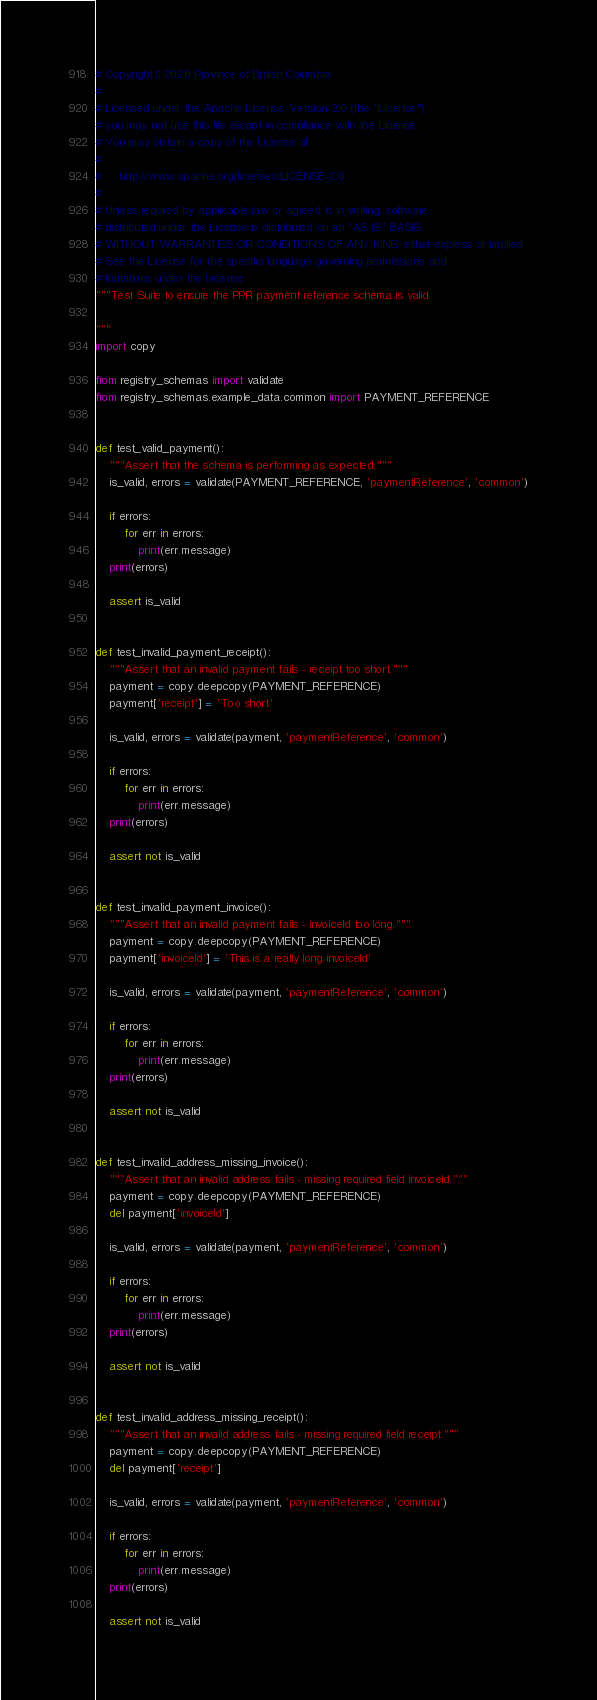Convert code to text. <code><loc_0><loc_0><loc_500><loc_500><_Python_># Copyright © 2020 Province of British Columbia
#
# Licensed under the Apache License, Version 2.0 (the "License");
# you may not use this file except in compliance with the License.
# You may obtain a copy of the License at
#
#     http://www.apache.org/licenses/LICENSE-2.0
#
# Unless required by applicable law or agreed to in writing, software
# distributed under the License is distributed on an "AS IS" BASIS,
# WITHOUT WARRANTIES OR CONDITIONS OF ANY KIND, either express or implied.
# See the License for the specific language governing permissions and
# limitations under the License.
"""Test Suite to ensure the PPR payment reference schema is valid.

"""
import copy

from registry_schemas import validate
from registry_schemas.example_data.common import PAYMENT_REFERENCE


def test_valid_payment():
    """Assert that the schema is performing as expected."""
    is_valid, errors = validate(PAYMENT_REFERENCE, 'paymentReference', 'common')

    if errors:
        for err in errors:
            print(err.message)
    print(errors)

    assert is_valid


def test_invalid_payment_receipt():
    """Assert that an invalid payment fails - receipt too short."""
    payment = copy.deepcopy(PAYMENT_REFERENCE)
    payment['receipt'] = 'Too short'

    is_valid, errors = validate(payment, 'paymentReference', 'common')

    if errors:
        for err in errors:
            print(err.message)
    print(errors)

    assert not is_valid


def test_invalid_payment_invoice():
    """Assert that an invalid payment fails - invoiceId too long."""
    payment = copy.deepcopy(PAYMENT_REFERENCE)
    payment['invoiceId'] = 'This is a really long invoiceId'

    is_valid, errors = validate(payment, 'paymentReference', 'common')

    if errors:
        for err in errors:
            print(err.message)
    print(errors)

    assert not is_valid


def test_invalid_address_missing_invoice():
    """Assert that an invalid address fails - missing required field invoiceId."""
    payment = copy.deepcopy(PAYMENT_REFERENCE)
    del payment['invoiceId']

    is_valid, errors = validate(payment, 'paymentReference', 'common')

    if errors:
        for err in errors:
            print(err.message)
    print(errors)

    assert not is_valid


def test_invalid_address_missing_receipt():
    """Assert that an invalid address fails - missing required field receipt."""
    payment = copy.deepcopy(PAYMENT_REFERENCE)
    del payment['receipt']

    is_valid, errors = validate(payment, 'paymentReference', 'common')

    if errors:
        for err in errors:
            print(err.message)
    print(errors)

    assert not is_valid
</code> 